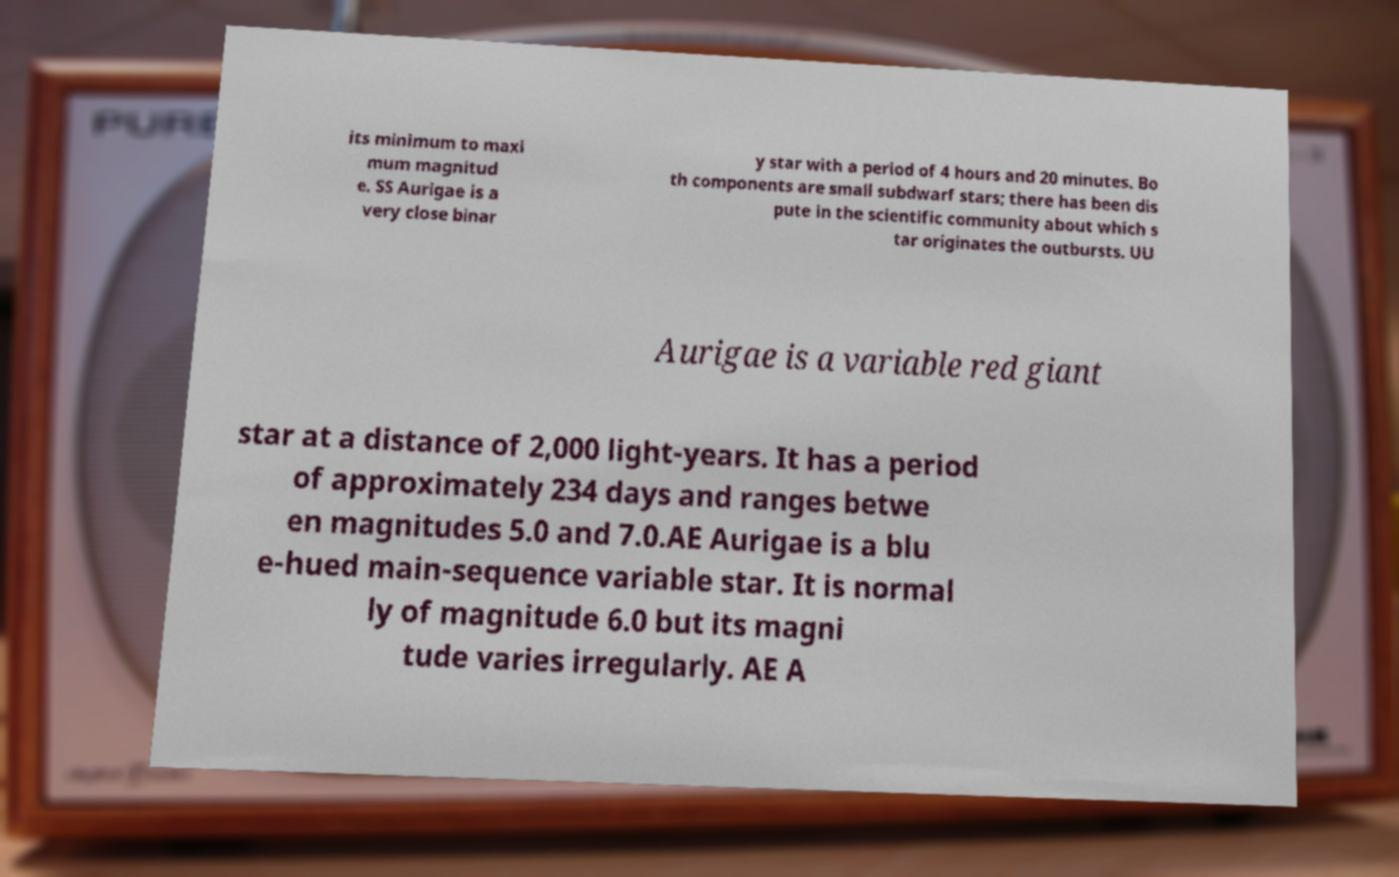I need the written content from this picture converted into text. Can you do that? its minimum to maxi mum magnitud e. SS Aurigae is a very close binar y star with a period of 4 hours and 20 minutes. Bo th components are small subdwarf stars; there has been dis pute in the scientific community about which s tar originates the outbursts. UU Aurigae is a variable red giant star at a distance of 2,000 light-years. It has a period of approximately 234 days and ranges betwe en magnitudes 5.0 and 7.0.AE Aurigae is a blu e-hued main-sequence variable star. It is normal ly of magnitude 6.0 but its magni tude varies irregularly. AE A 